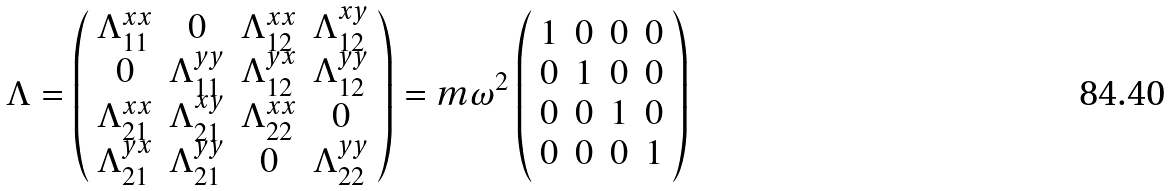<formula> <loc_0><loc_0><loc_500><loc_500>\Lambda = \left ( \begin{array} { c c c c } \Lambda _ { 1 1 } ^ { x x } & 0 & \Lambda _ { 1 2 } ^ { x x } & \Lambda _ { 1 2 } ^ { x y } \\ 0 & \Lambda _ { 1 1 } ^ { y y } & \Lambda _ { 1 2 } ^ { y x } & \Lambda _ { 1 2 } ^ { y y } \\ \Lambda _ { 2 1 } ^ { x x } & \Lambda _ { 2 1 } ^ { x y } & \Lambda _ { 2 2 } ^ { x x } & 0 \\ \Lambda _ { 2 1 } ^ { y x } & \Lambda _ { 2 1 } ^ { y y } & 0 & \Lambda _ { 2 2 } ^ { y y } \end{array} \right ) = m \omega ^ { 2 } \left ( \begin{array} { c c c c } 1 & 0 & 0 & 0 \\ 0 & 1 & 0 & 0 \\ 0 & 0 & 1 & 0 \\ 0 & 0 & 0 & 1 \end{array} \right )</formula> 